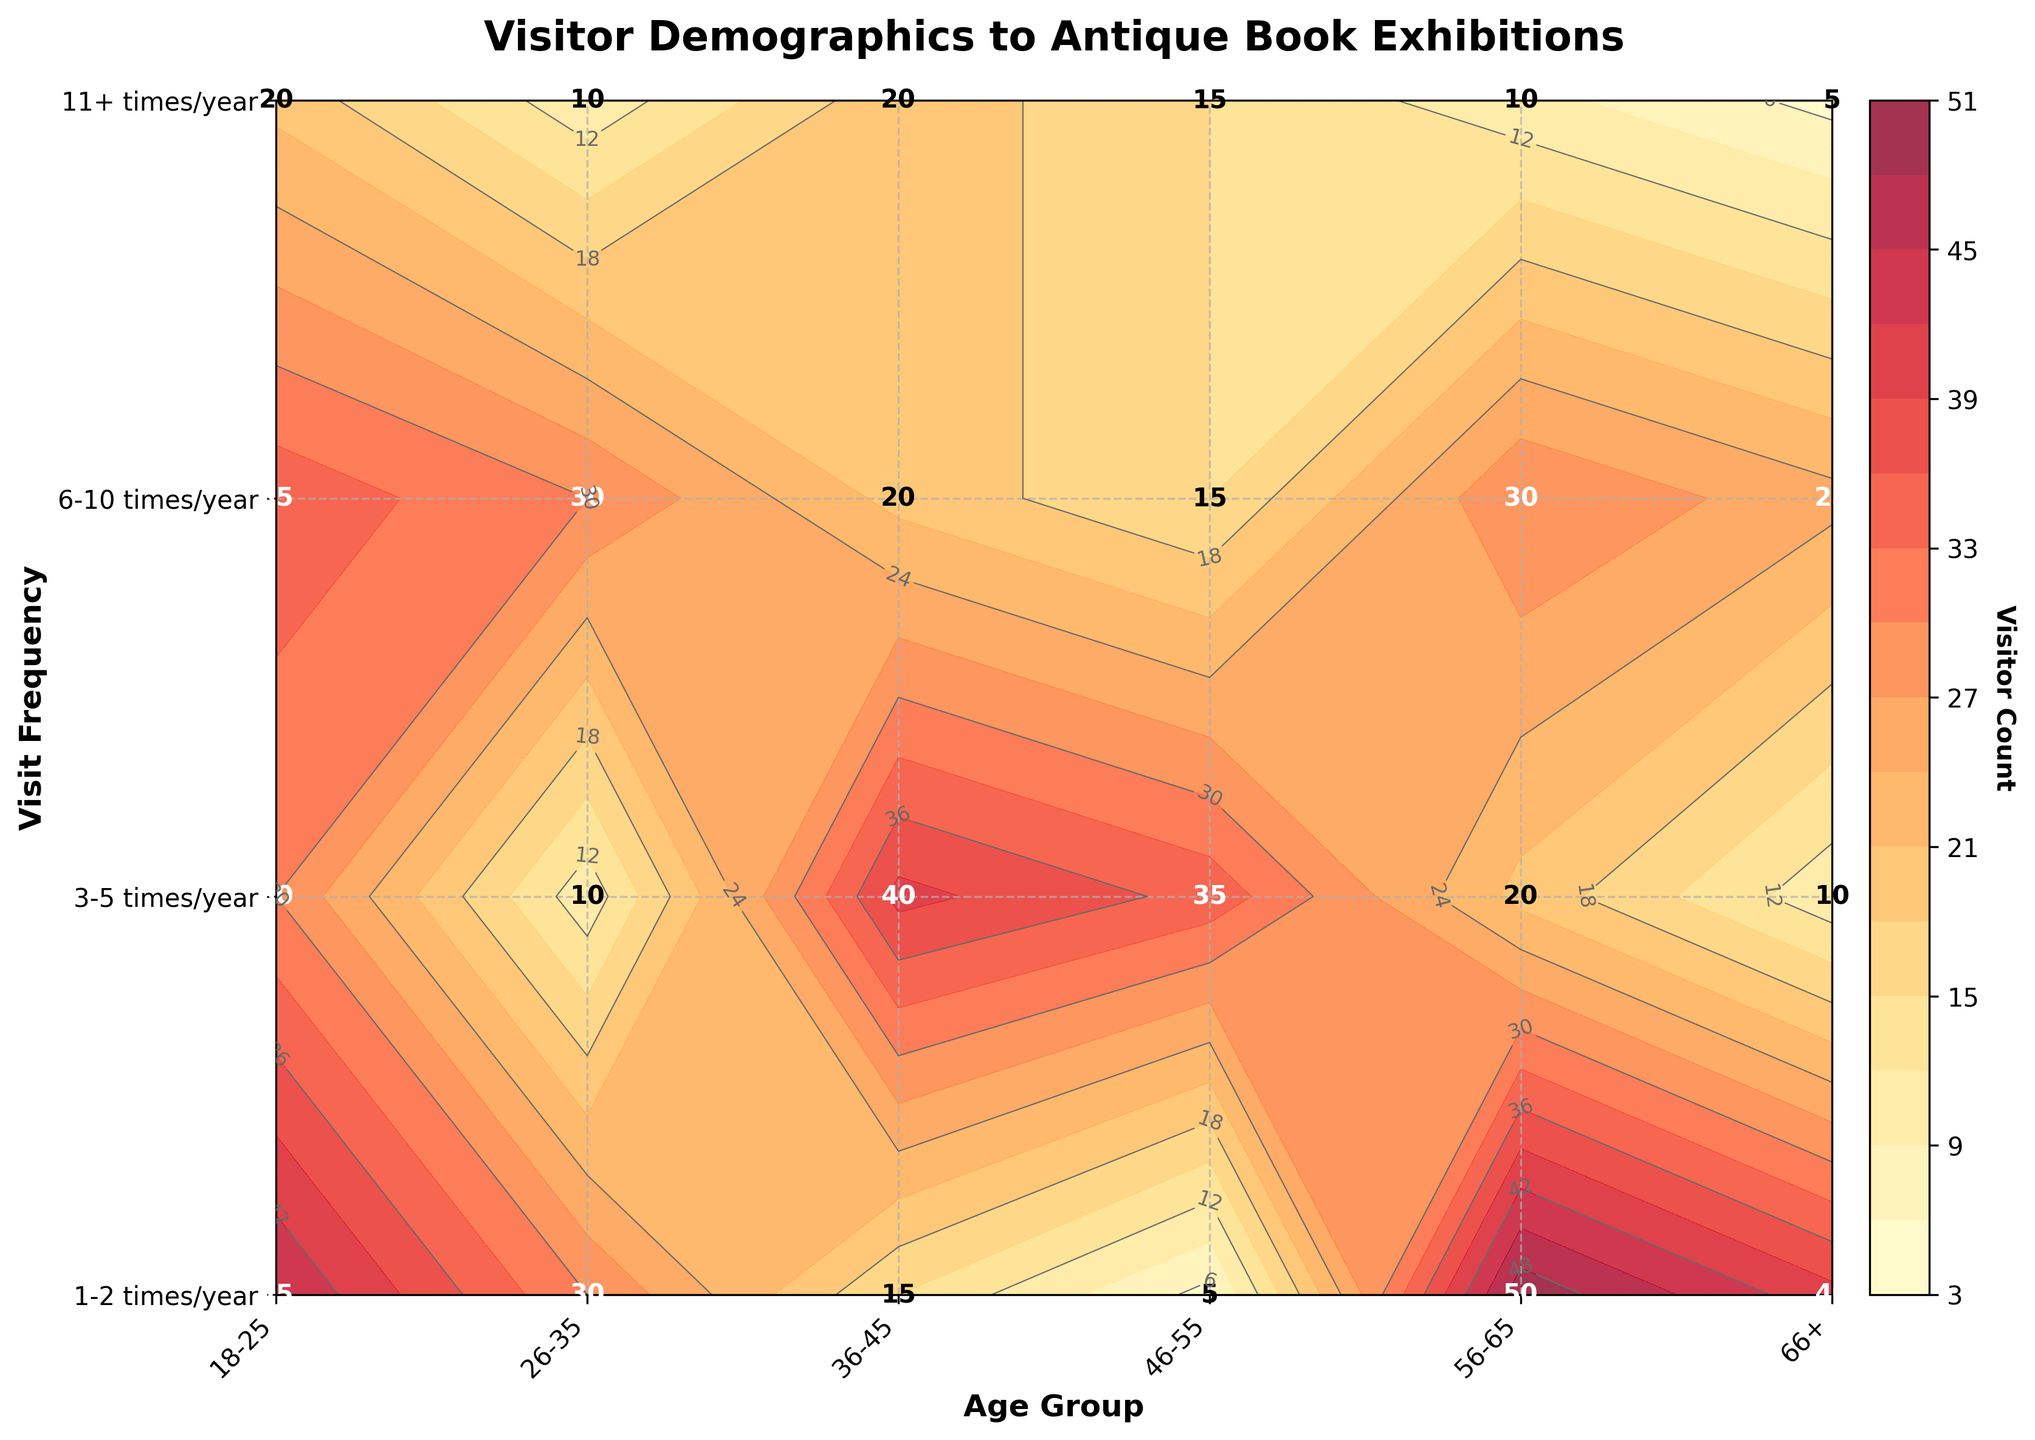What is the title of the graph? The title of the graph is usually placed at the top and often in a larger or bolder font compared to other text on the graph. In this case, it reads "Visitor Demographics to Antique Book Exhibitions."
Answer: Visitor Demographics to Antique Book Exhibitions Which age group has the highest visitor count for the category "3-5 times/year"? To determine this, locate the age group on the x-axis and the visit frequency "3-5 times/year" on the y-axis. Identify the highest labeled value in that row. The label for the 26-35 age group shows the highest value, which is 40.
Answer: 26-35 What is the total visitor count for the "46-55" age group? For this question, sum the visitor counts for all visit frequencies within the "46-55" age group. This includes: 35 (1-2 times/year) + 30 (3-5 times/year) + 20 (6-10 times/year) + 15 (11+ times/year) = 100.
Answer: 100 Which visit frequency category has the most visitors overall, and what is the total count for that category? Sum the visitor counts for each visit frequency across all age groups, then identify the highest total. For "1-2 times/year," the total is 220; for "3-5 times/year" is 175; for "6-10 times/year" is 115; for "11+ times/year" is 55. The largest total is for the "1-2 times/year" category: 220 visitors.
Answer: 1-2 times/year, 220 Between which two age groups is the largest gap in visitor count for the "6-10 times/year" frequency? Examine the visitor counts for each age group under the "6-10 times/year" frequency. Calculate the gaps: (30 - 20) for "26-35" to "36-45", (20 - 10) for "46-55" to "56-65". The largest gap is between "26-35" and "36-45" with a difference of 10 visitors.
Answer: 26-35 and 36-45, gap of 10 visitors Which age group has the lowest visitor count in the "11+ times/year" category? Identify the age group with the smallest labeled value in the "11+ times/year" category by checking each entry in the last row. The 18-25 and 66+ age groups both show the lowest count, which is 5.
Answer: 18-25 and 66+ What is the average visitor count for the "56-65" age group across all visit frequencies? To determine the average, sum the visitor counts for the "56-65" age group and divide by the number of frequencies. (30 + 25 + 20 + 10) / 4 = 85 / 4 = 21.25.
Answer: 21.25 Is there any age group where the visitor count decreases as the visit frequency increases? To determine this, check each age group's visitor counts across visit frequencies. For the "18-25" and "66+" age groups, the count decreases consistently: 45 -> 30 -> 15 -> 5 and 20 -> 15 -> 10 -> 5 respectively.
Answer: 18-25 and 66+ What is the combined visitor count for people aged 36-45 attending "1-2 times/year" and "11+ times/year"? Add the visitor count for "36-45" in the "1-2 times/year" and "11+ times/year" categories: 40 + 10 = 50.
Answer: 50 